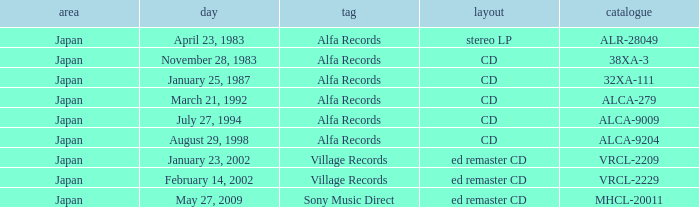When is the date for the stereo lp format? April 23, 1983. 